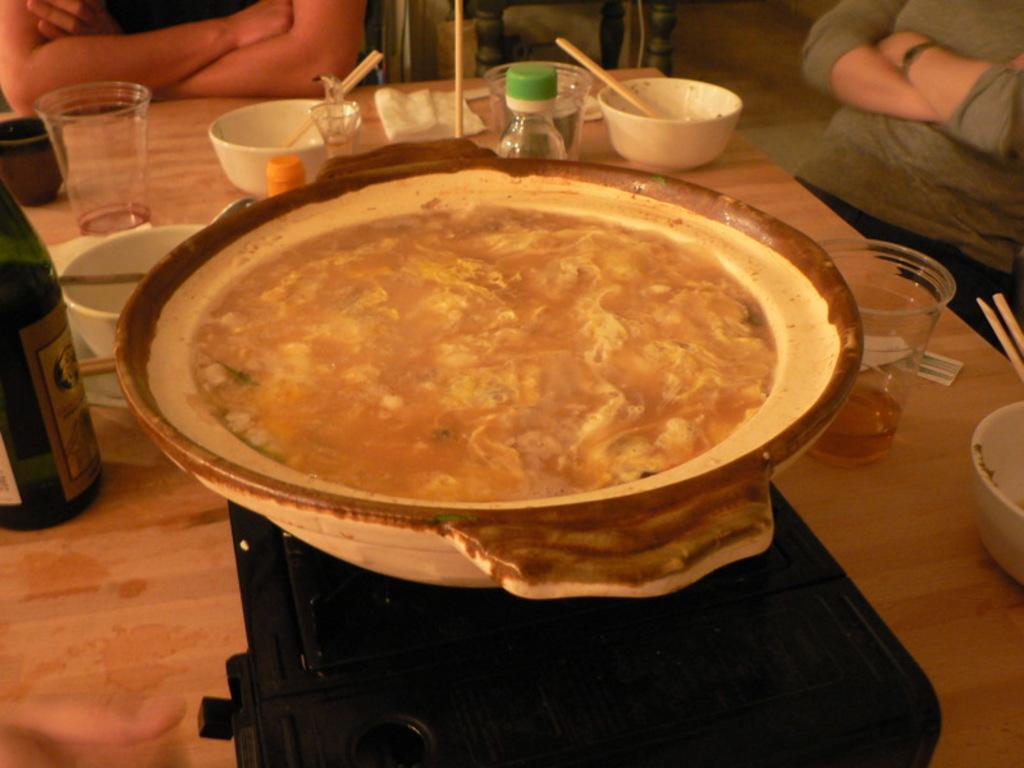Can you describe this image briefly? There are glasses,cups,bottles,chopsticks,tissue papers and food in a bowl and a wine bottle on the table. Beside the table there are two persons. 